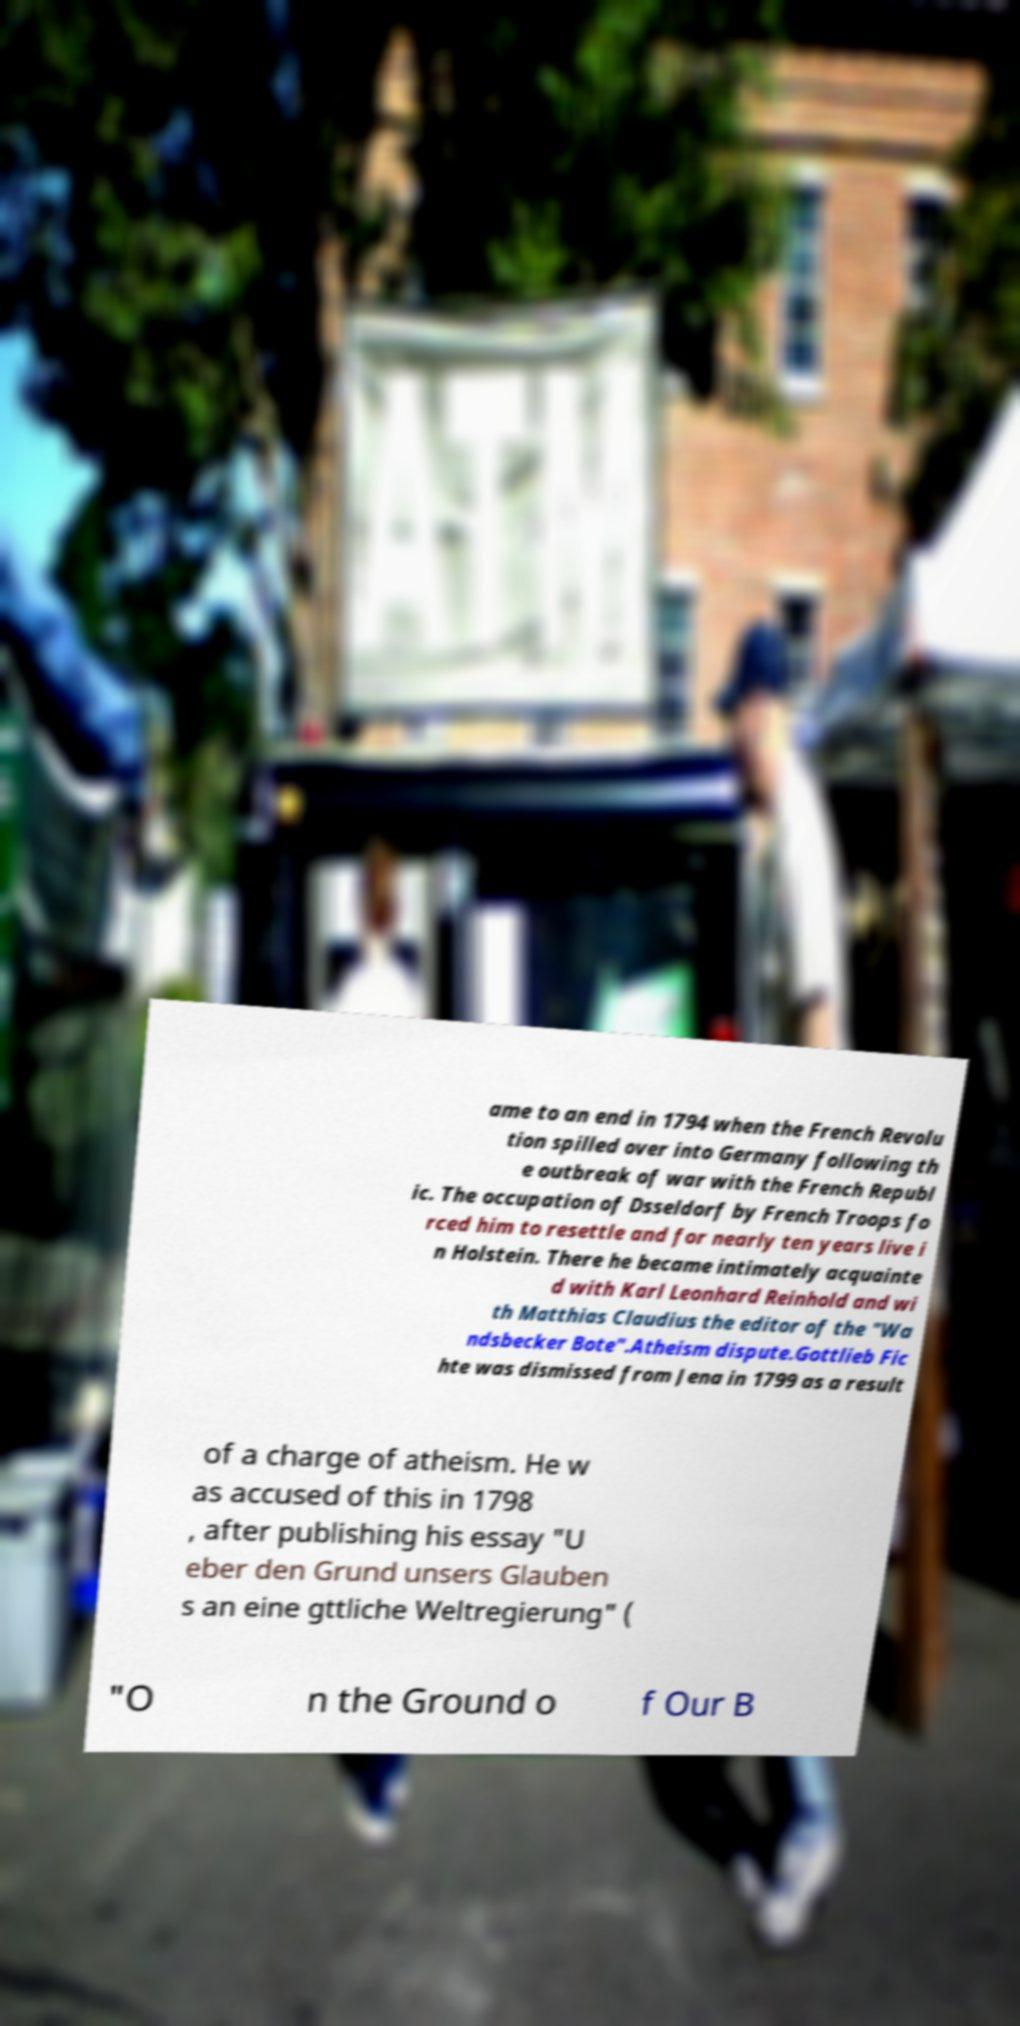I need the written content from this picture converted into text. Can you do that? ame to an end in 1794 when the French Revolu tion spilled over into Germany following th e outbreak of war with the French Republ ic. The occupation of Dsseldorf by French Troops fo rced him to resettle and for nearly ten years live i n Holstein. There he became intimately acquainte d with Karl Leonhard Reinhold and wi th Matthias Claudius the editor of the "Wa ndsbecker Bote".Atheism dispute.Gottlieb Fic hte was dismissed from Jena in 1799 as a result of a charge of atheism. He w as accused of this in 1798 , after publishing his essay "U eber den Grund unsers Glauben s an eine gttliche Weltregierung" ( "O n the Ground o f Our B 